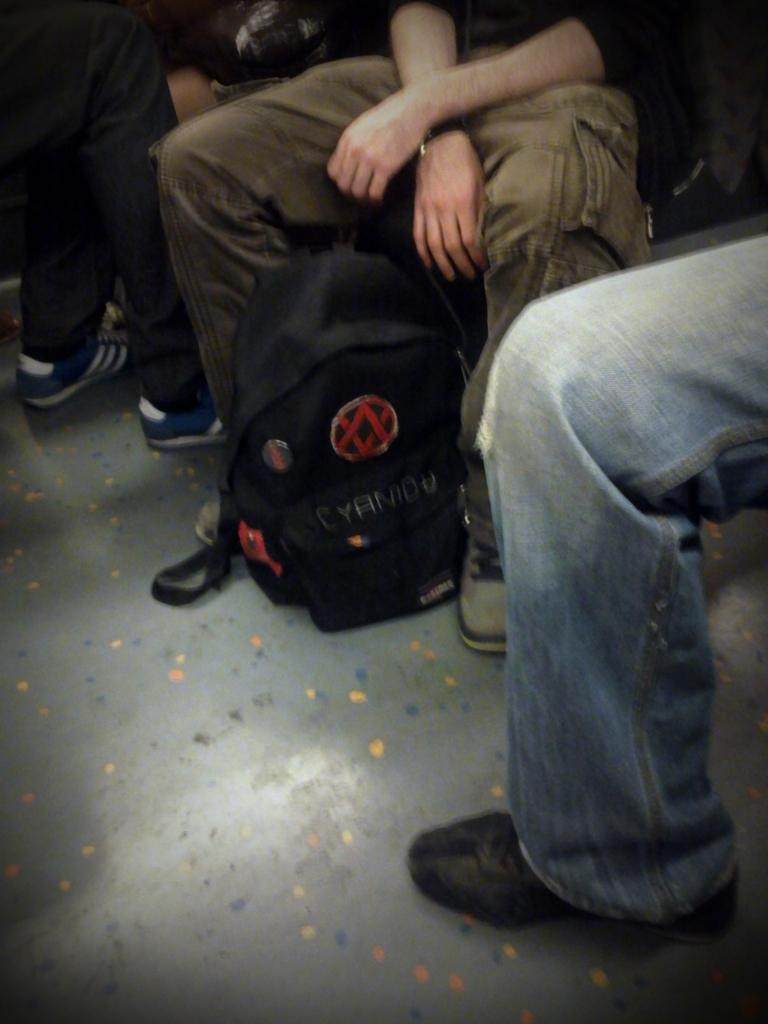How many people are present in the image? There are two people sitting and one person standing in the image. What is the standing person doing in the image? The standing person is on the floor in the image. Is there any object on the floor besides the standing person? Yes, there is a bag on the floor in the image. What invention is the duck using to communicate with the people in the image? There is no duck present in the image, so it is not possible to determine what invention might be used for communication. 